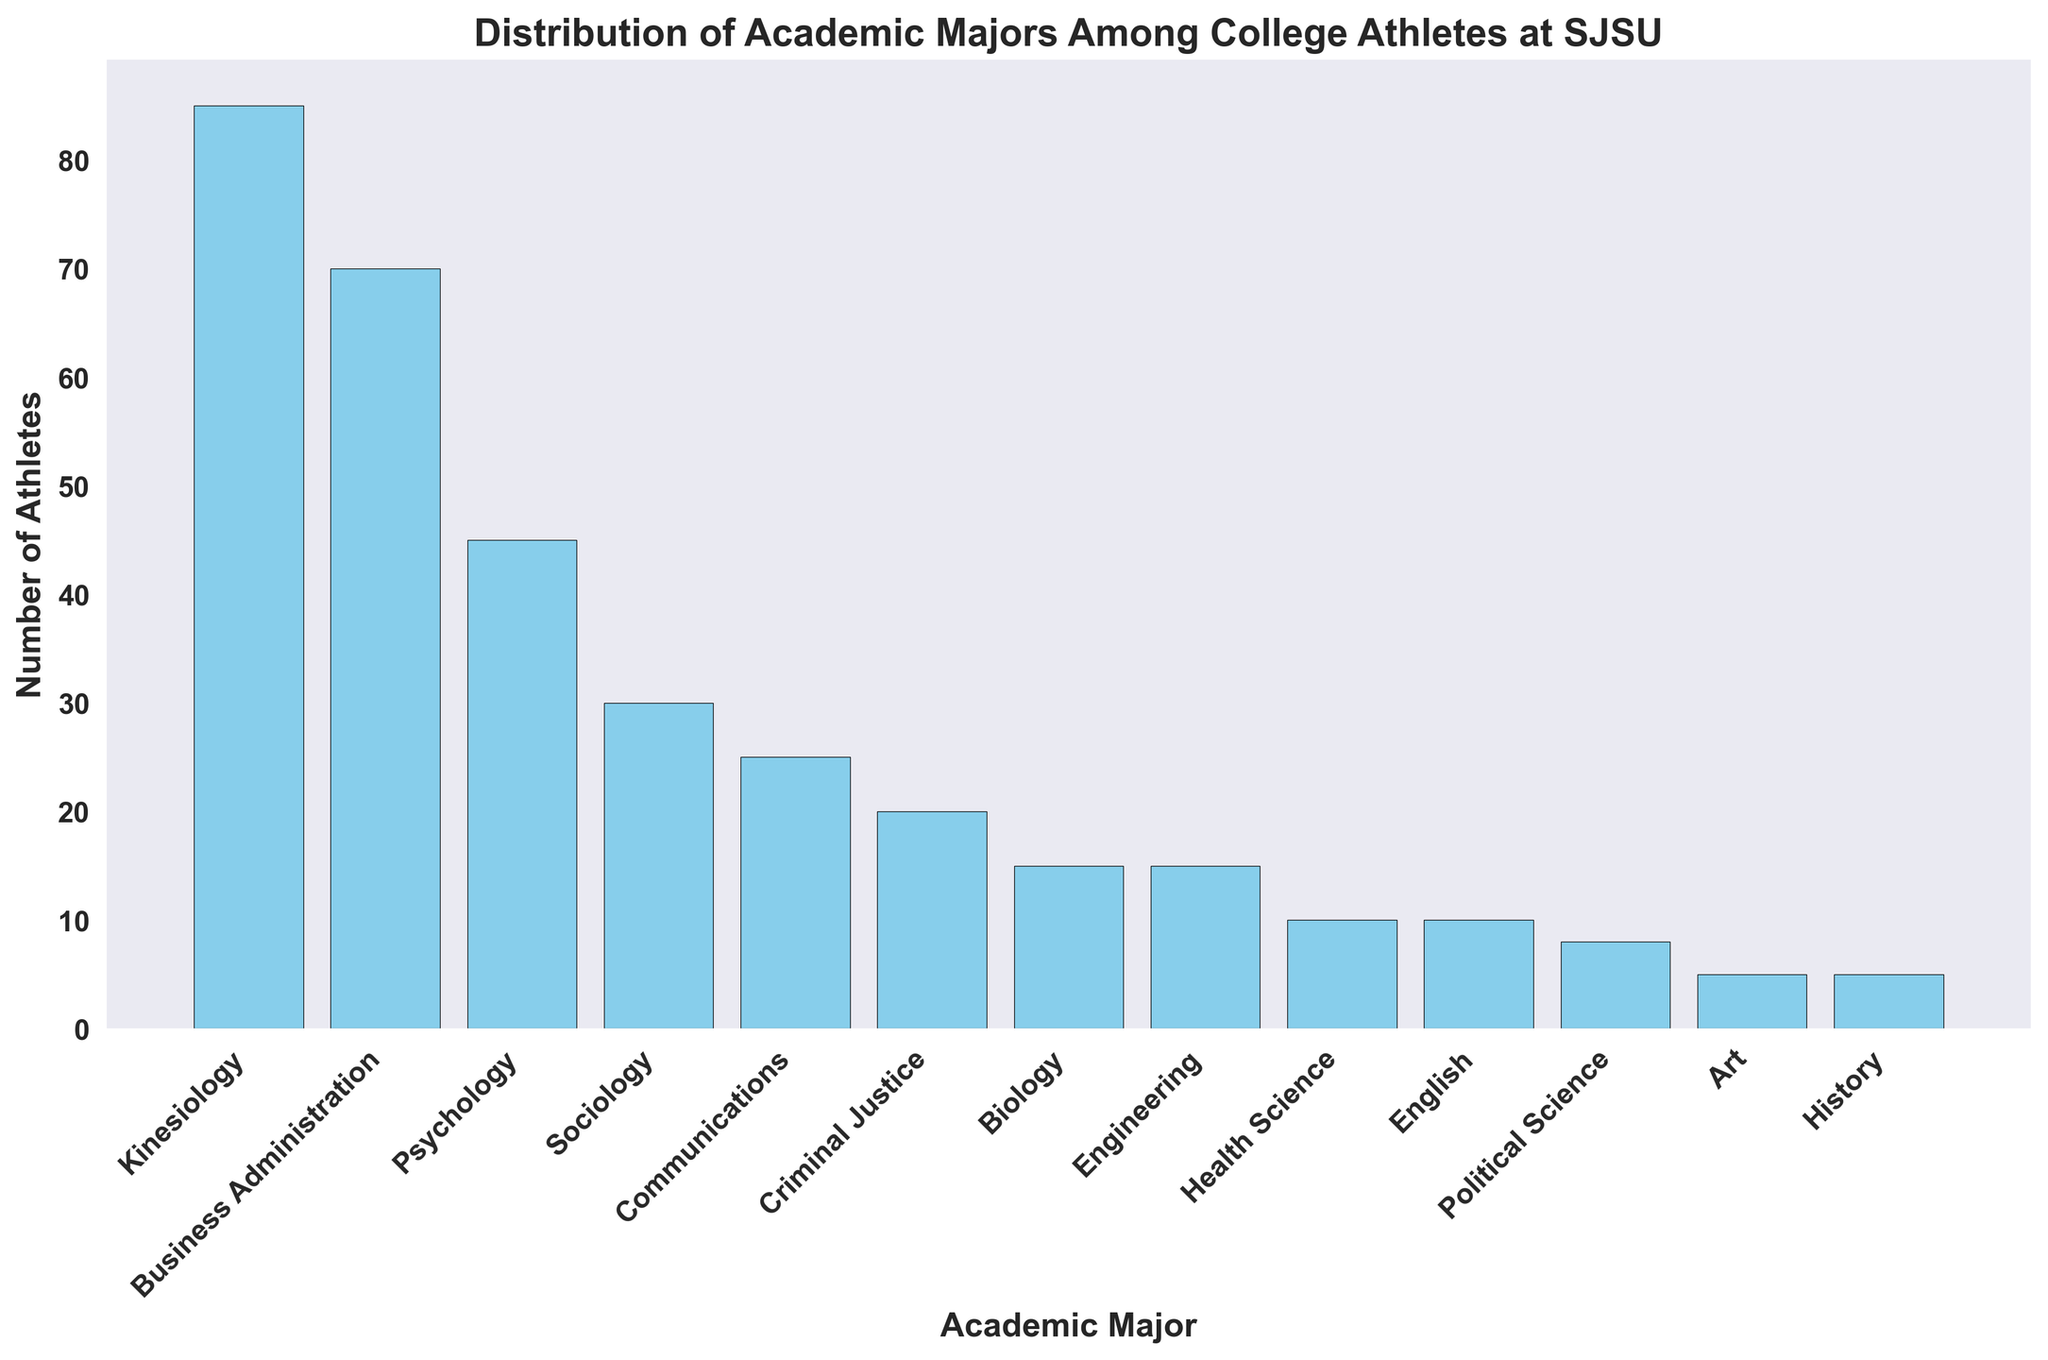What's the most common academic major among college athletes at SJSU? By observing the heights of the bars, we can see which one is the tallest. The tallest bar represents the major 'Kinesiology'.
Answer: Kinesiology Which academic major has the least number of athletes? By observing the bar heights, the shortest bars represent the majors with the least counts. 'Art' and 'History' both have the shortest bars.
Answer: Art, History How many more athletes are majoring in Kinesiology compared to Psychology? The number of Kinesiology majors is 85 and the number of Psychology majors is 45. Subtracting these gives 85 - 45 = 40.
Answer: 40 What is the total number of athletes in majors with fewer than 20 students? Adding the counts of Criminal Justice (20), Biology (15), Engineering (15), Health Science (10), English (10), Political Science (8), Art (5), and History (5) gives 20 + 15 + 15 + 10 + 10 + 8 + 5 + 5 = 88.
Answer: 88 Are there more athletes majoring in Business Administration or Communications? Comparing the heights of the bars for 'Business Administration' and 'Communications', the bar for 'Business Administration' is taller.
Answer: Business Administration Which majors are chosen by exactly 15 athletes? By looking at the plot, the bars with heights corresponding to the count of 15 are Biology and Engineering.
Answer: Biology, Engineering What is the combined number of athletes majoring in Sociology and Communications? By adding the counts of Sociology (30) and Communications (25), we get 30 + 25 = 55.
Answer: 55 Is the number of athletes majoring in Criminal Justice greater than those majoring in Health Science? By comparing the bar heights, Criminal Justice has a height of 20, while Health Science has a height of 10, so Criminal Justice has more athletes.
Answer: Yes What proportion of athletes are majoring in Kinesiology out of the total shown? First, sum all the athlete counts. The total is 85 + 70 + 45 + 30 + 25 + 20 + 15 + 15 + 10 + 10 + 8 + 5 + 5 = 338. The proportion is 85 / 338 ≈ 0.251 or 25.1%.
Answer: 25.1% How do the counts of athletes majoring in Business Administration and Psychology compare? The count for Business Administration is 70, and the count for Psychology is 45. Comparing these, Business Administration has more athletes.
Answer: Business Administration 